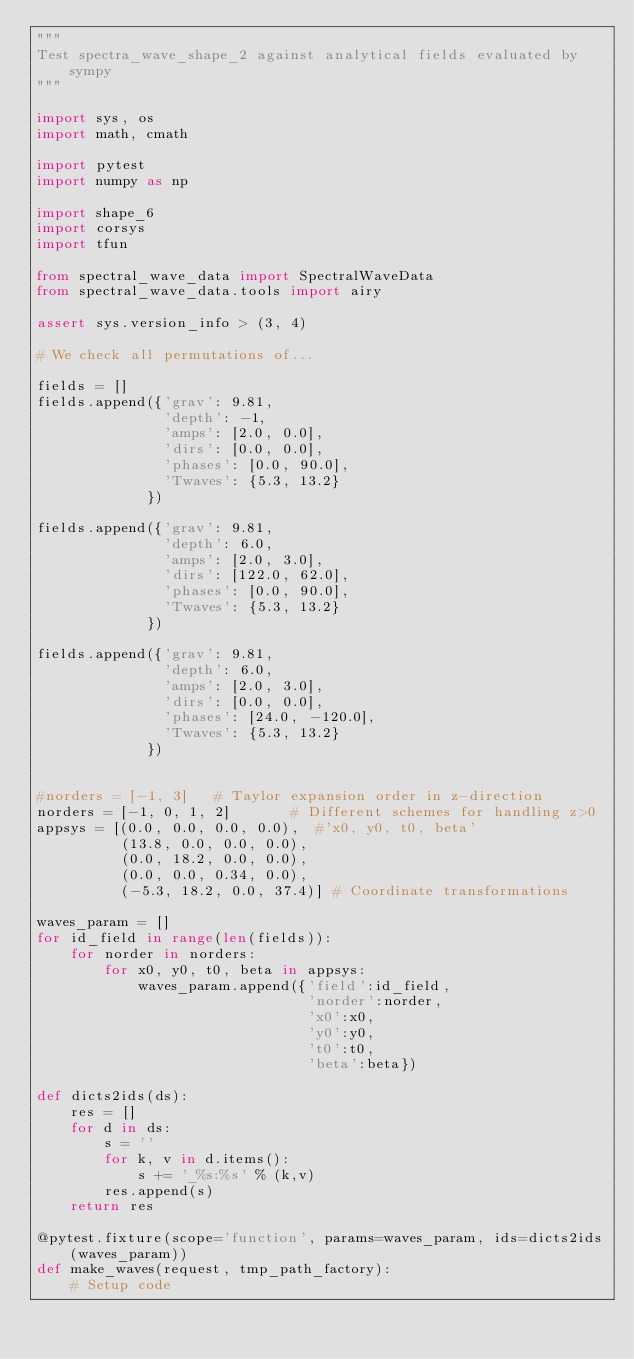Convert code to text. <code><loc_0><loc_0><loc_500><loc_500><_Python_>"""
Test spectra_wave_shape_2 against analytical fields evaluated by sympy
"""

import sys, os
import math, cmath

import pytest
import numpy as np

import shape_6
import corsys
import tfun

from spectral_wave_data import SpectralWaveData
from spectral_wave_data.tools import airy

assert sys.version_info > (3, 4)

# We check all permutations of...

fields = []
fields.append({'grav': 9.81,
               'depth': -1,
               'amps': [2.0, 0.0],
               'dirs': [0.0, 0.0],
               'phases': [0.0, 90.0],
               'Twaves': {5.3, 13.2}
             })

fields.append({'grav': 9.81,
               'depth': 6.0,
               'amps': [2.0, 3.0],
               'dirs': [122.0, 62.0],
               'phases': [0.0, 90.0],
               'Twaves': {5.3, 13.2}
             })

fields.append({'grav': 9.81,
               'depth': 6.0,
               'amps': [2.0, 3.0],
               'dirs': [0.0, 0.0],
               'phases': [24.0, -120.0],
               'Twaves': {5.3, 13.2}
             })


#norders = [-1, 3]   # Taylor expansion order in z-direction
norders = [-1, 0, 1, 2]       # Different schemes for handling z>0
appsys = [(0.0, 0.0, 0.0, 0.0),  #'x0, y0, t0, beta'
          (13.8, 0.0, 0.0, 0.0),
          (0.0, 18.2, 0.0, 0.0),
          (0.0, 0.0, 0.34, 0.0),
          (-5.3, 18.2, 0.0, 37.4)] # Coordinate transformations

waves_param = []
for id_field in range(len(fields)):
    for norder in norders:
        for x0, y0, t0, beta in appsys:
            waves_param.append({'field':id_field,
                                'norder':norder,
                                'x0':x0,
                                'y0':y0,
                                't0':t0,
                                'beta':beta})

def dicts2ids(ds):
    res = []
    for d in ds:
        s = ''
        for k, v in d.items():
            s += '_%s:%s' % (k,v)
        res.append(s)
    return res

@pytest.fixture(scope='function', params=waves_param, ids=dicts2ids(waves_param))
def make_waves(request, tmp_path_factory):
    # Setup code</code> 